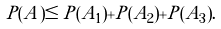<formula> <loc_0><loc_0><loc_500><loc_500>P ( A ) \leq P ( A _ { 1 } ) + P ( A _ { 2 } ) + P ( A _ { 3 } ) .</formula> 